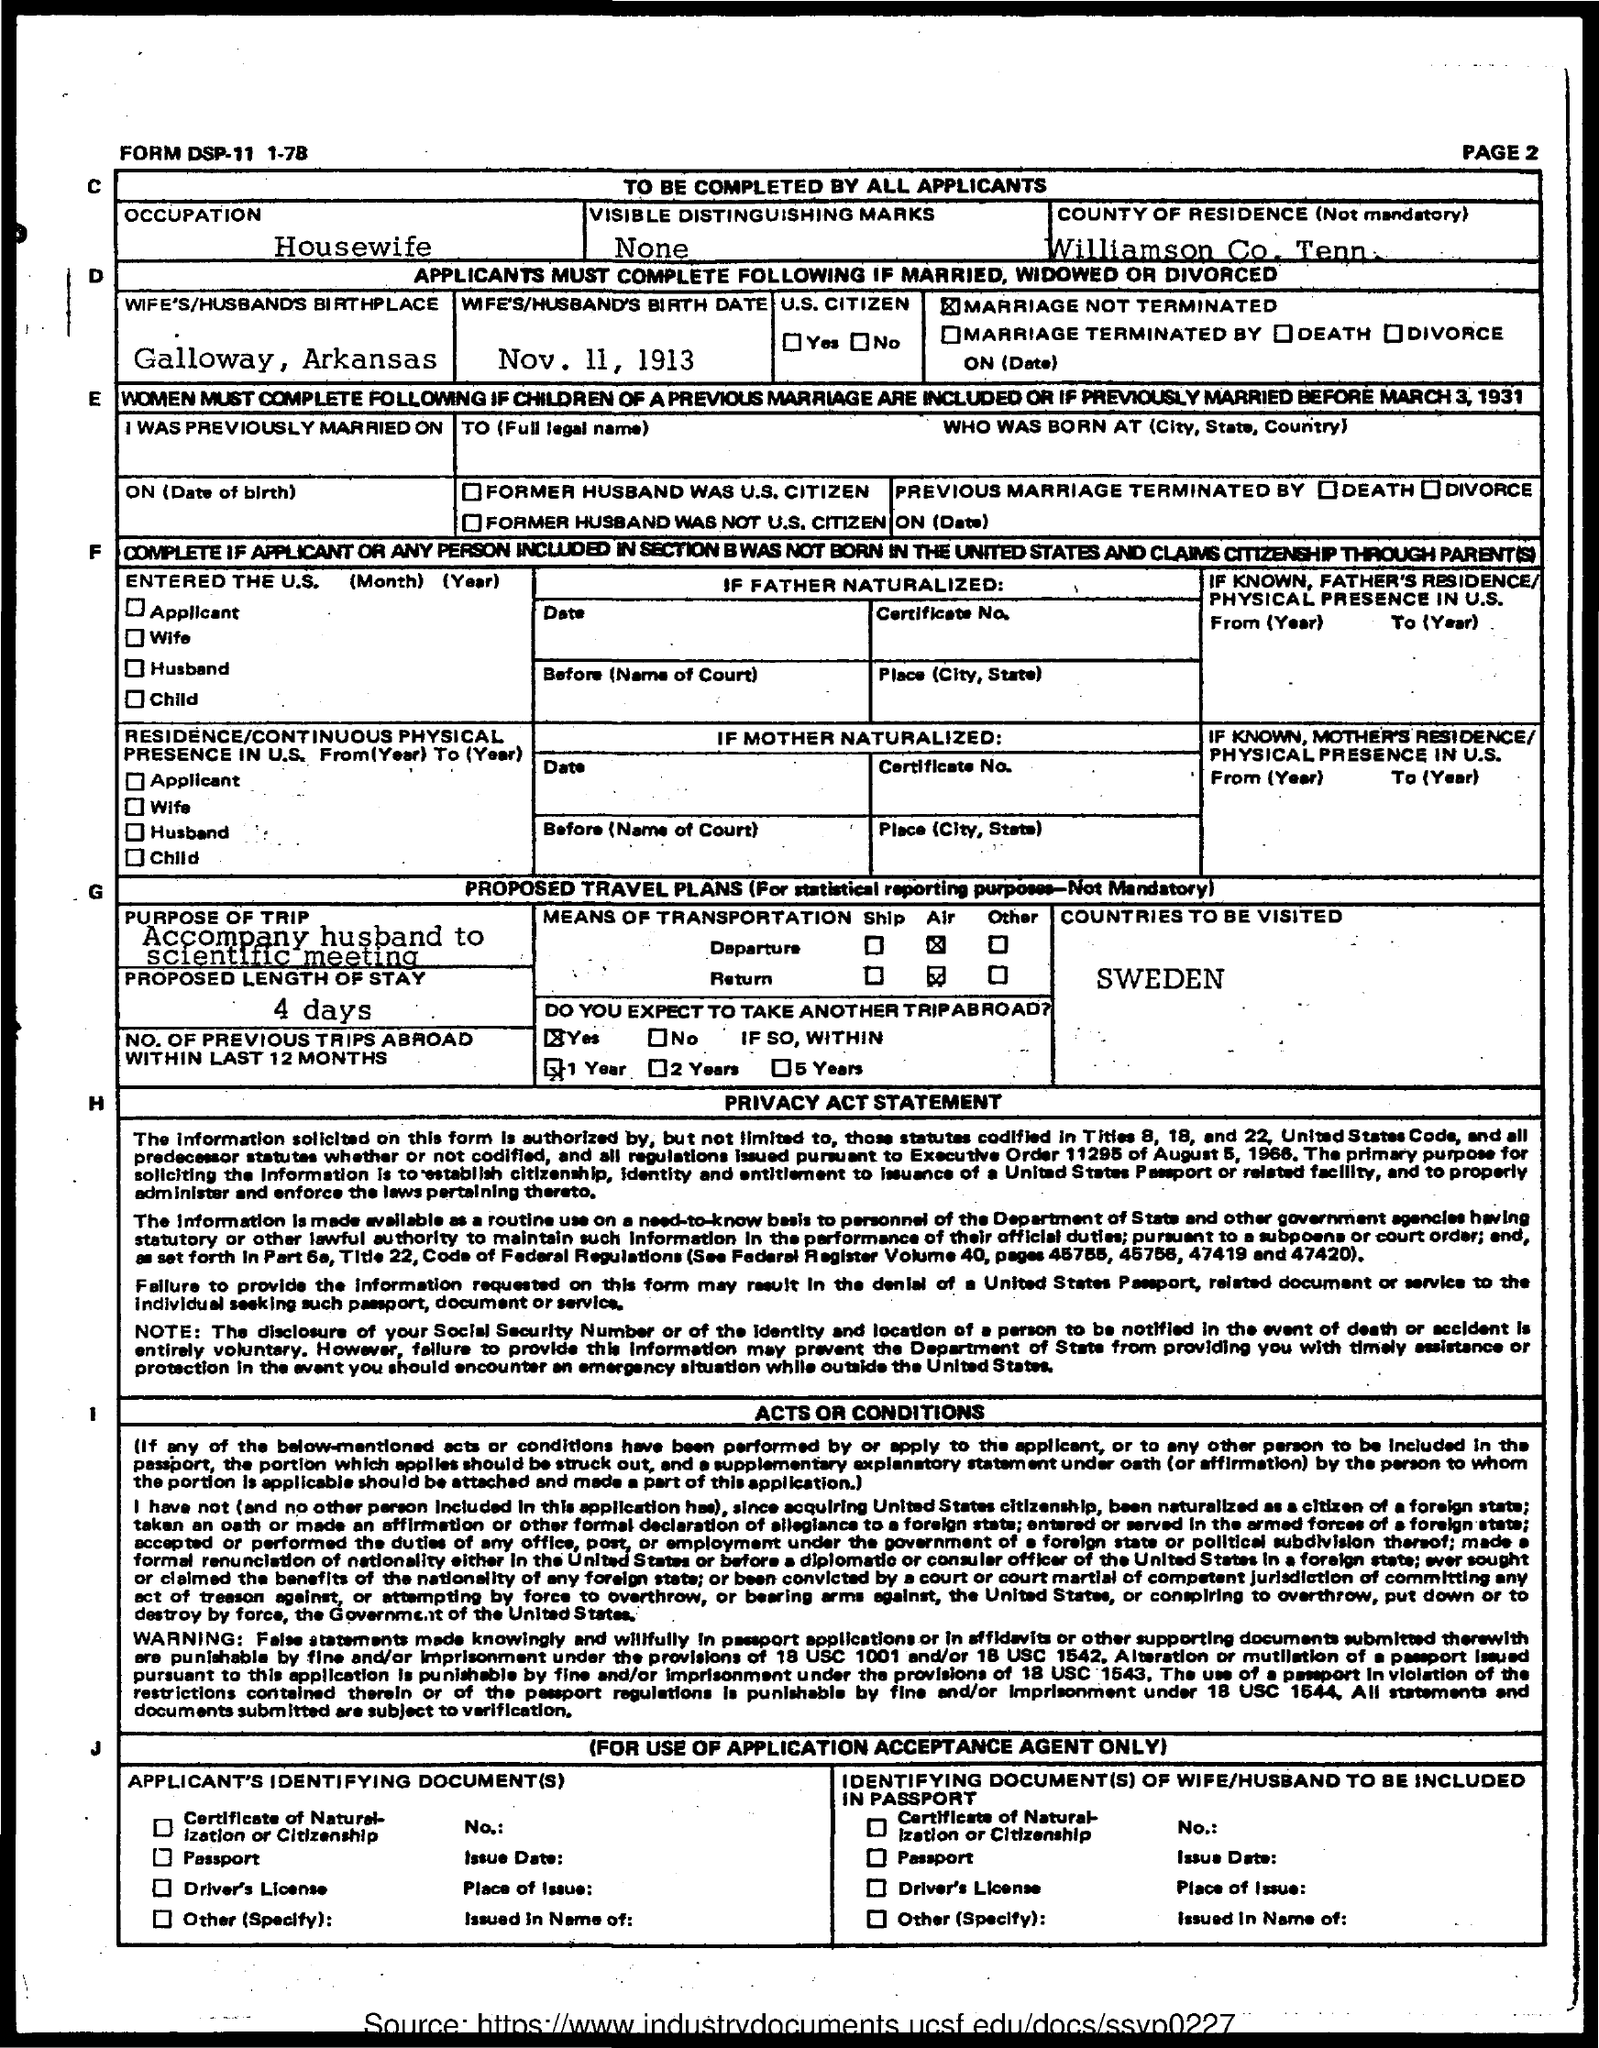Highlight a few significant elements in this photo. The countries to be visited, as mentioned in the given form, are Sweden. The length of stay proposed in the given form is 4 days. The occupation mentioned in the given page is that of a housewife. The wife's birth date is November 11, 1913. The given form is incomplete and does not provide sufficient information to determine the purpose of the trip mentioned. 